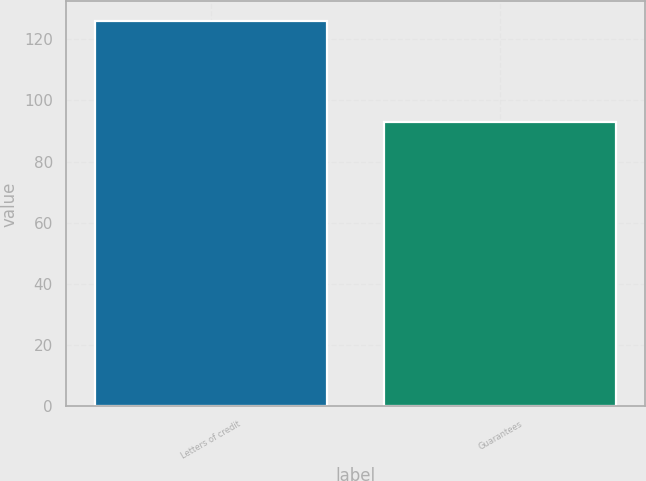<chart> <loc_0><loc_0><loc_500><loc_500><bar_chart><fcel>Letters of credit<fcel>Guarantees<nl><fcel>126<fcel>93<nl></chart> 